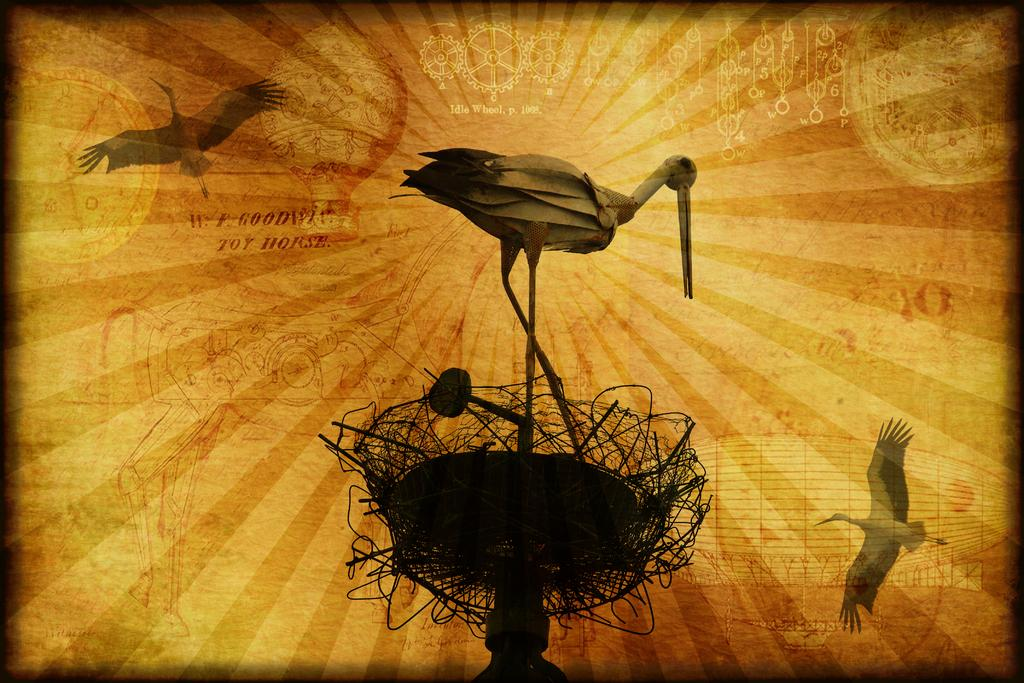What is featured on the poster in the image? The poster contains images of three birds. Is there any other structure or object in the image besides the poster? Yes, there is a stand in the image. What can be found on the poster or stand in terms of written information? There are texts visible on the poster or stand. Are there any other images or illustrations on the poster or stand besides the birds? Yes, there are other images present on the poster or stand. Where is the clock located in the image? There is no clock present in the image. What type of hook can be seen holding the poster in the image? There is no hook visible in the image; the poster is not being held up by a hook. 